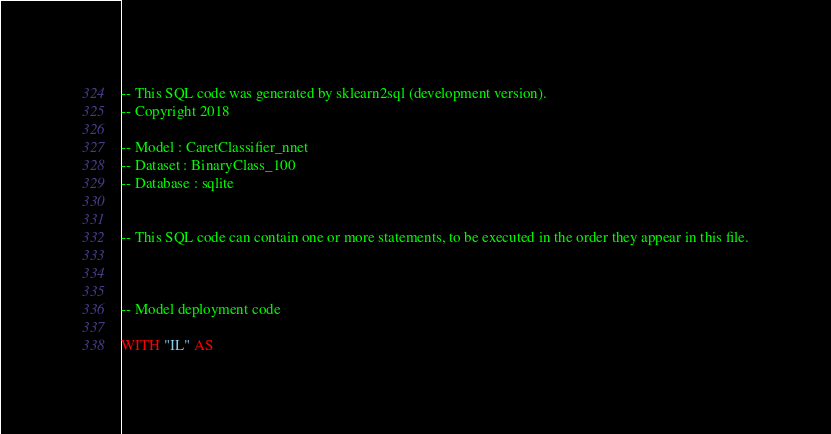Convert code to text. <code><loc_0><loc_0><loc_500><loc_500><_SQL_>-- This SQL code was generated by sklearn2sql (development version).
-- Copyright 2018

-- Model : CaretClassifier_nnet
-- Dataset : BinaryClass_100
-- Database : sqlite


-- This SQL code can contain one or more statements, to be executed in the order they appear in this file.



-- Model deployment code

WITH "IL" AS </code> 